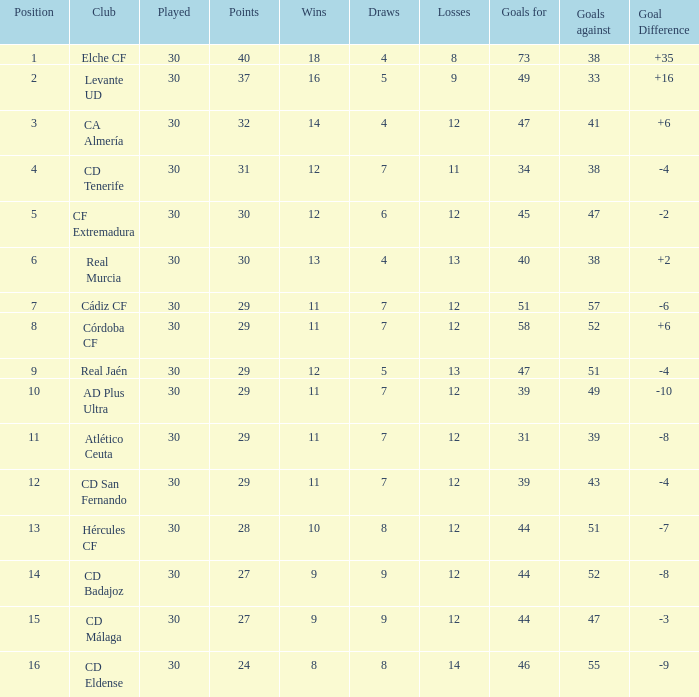With less than 14 wins and a goal difference of less than -4, what is the total number of goals? 51, 39, 31, 44, 44, 46. 